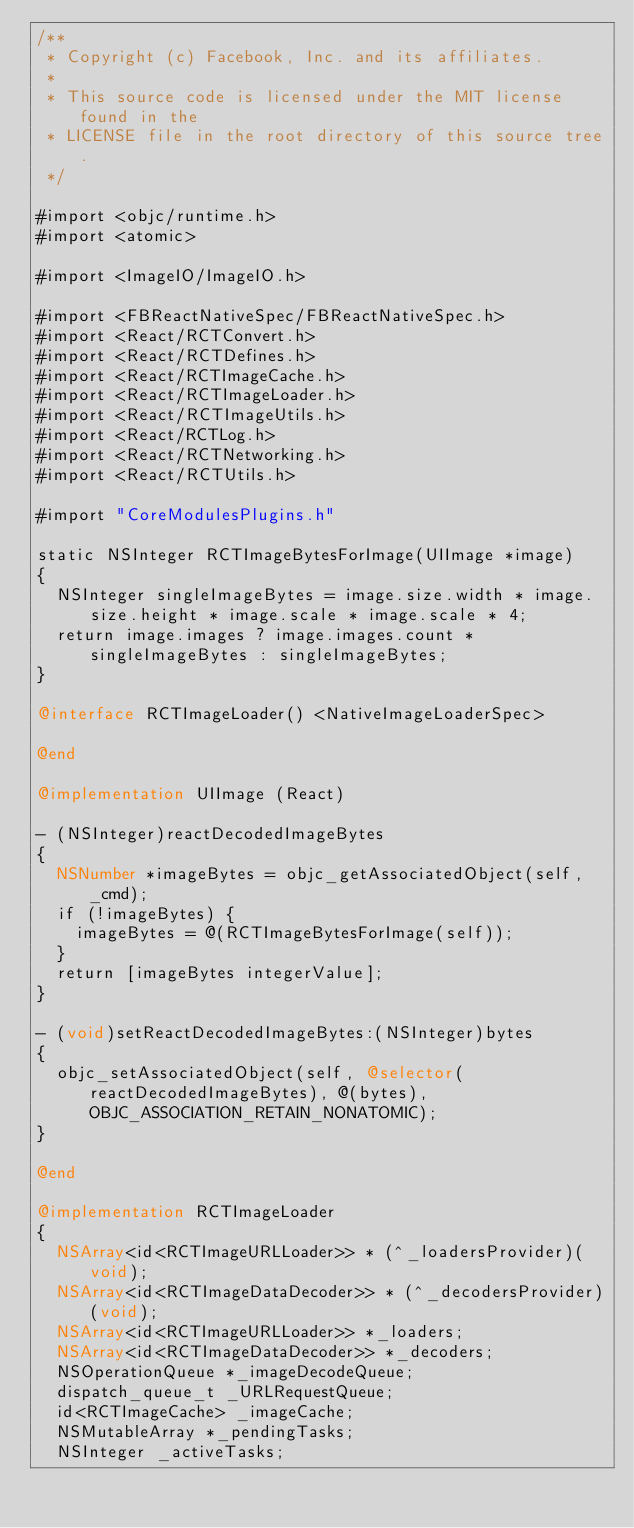<code> <loc_0><loc_0><loc_500><loc_500><_ObjectiveC_>/**
 * Copyright (c) Facebook, Inc. and its affiliates.
 *
 * This source code is licensed under the MIT license found in the
 * LICENSE file in the root directory of this source tree.
 */

#import <objc/runtime.h>
#import <atomic>

#import <ImageIO/ImageIO.h>

#import <FBReactNativeSpec/FBReactNativeSpec.h>
#import <React/RCTConvert.h>
#import <React/RCTDefines.h>
#import <React/RCTImageCache.h>
#import <React/RCTImageLoader.h>
#import <React/RCTImageUtils.h>
#import <React/RCTLog.h>
#import <React/RCTNetworking.h>
#import <React/RCTUtils.h>

#import "CoreModulesPlugins.h"

static NSInteger RCTImageBytesForImage(UIImage *image)
{
  NSInteger singleImageBytes = image.size.width * image.size.height * image.scale * image.scale * 4;
  return image.images ? image.images.count * singleImageBytes : singleImageBytes;
}

@interface RCTImageLoader() <NativeImageLoaderSpec>

@end

@implementation UIImage (React)

- (NSInteger)reactDecodedImageBytes
{
  NSNumber *imageBytes = objc_getAssociatedObject(self, _cmd);
  if (!imageBytes) {
    imageBytes = @(RCTImageBytesForImage(self));
  }
  return [imageBytes integerValue];
}

- (void)setReactDecodedImageBytes:(NSInteger)bytes
{
  objc_setAssociatedObject(self, @selector(reactDecodedImageBytes), @(bytes), OBJC_ASSOCIATION_RETAIN_NONATOMIC);
}

@end

@implementation RCTImageLoader
{
  NSArray<id<RCTImageURLLoader>> * (^_loadersProvider)(void);
  NSArray<id<RCTImageDataDecoder>> * (^_decodersProvider)(void);
  NSArray<id<RCTImageURLLoader>> *_loaders;
  NSArray<id<RCTImageDataDecoder>> *_decoders;
  NSOperationQueue *_imageDecodeQueue;
  dispatch_queue_t _URLRequestQueue;
  id<RCTImageCache> _imageCache;
  NSMutableArray *_pendingTasks;
  NSInteger _activeTasks;</code> 